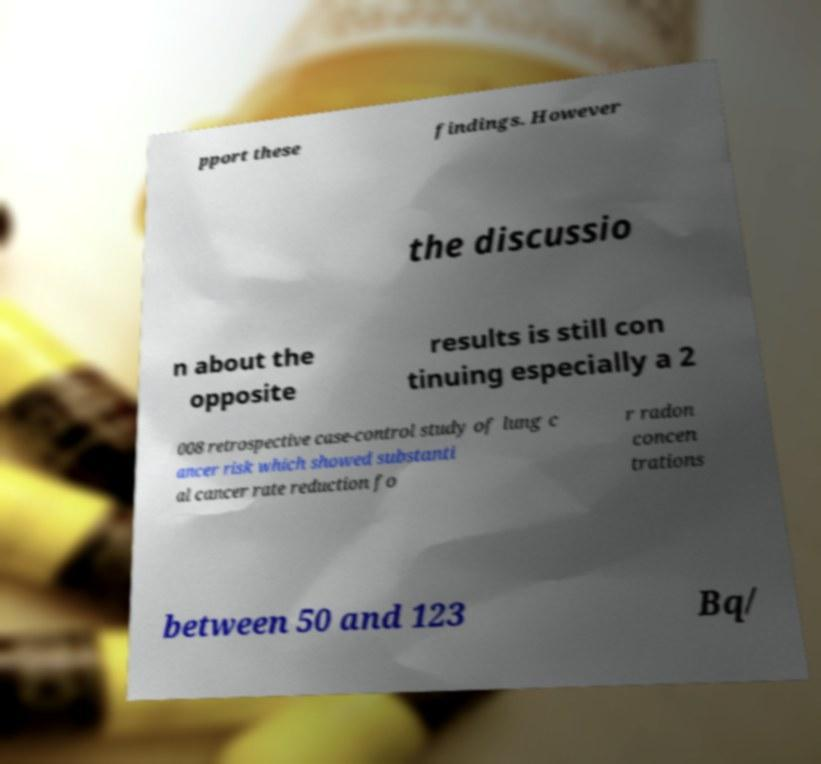Can you accurately transcribe the text from the provided image for me? pport these findings. However the discussio n about the opposite results is still con tinuing especially a 2 008 retrospective case-control study of lung c ancer risk which showed substanti al cancer rate reduction fo r radon concen trations between 50 and 123 Bq/ 